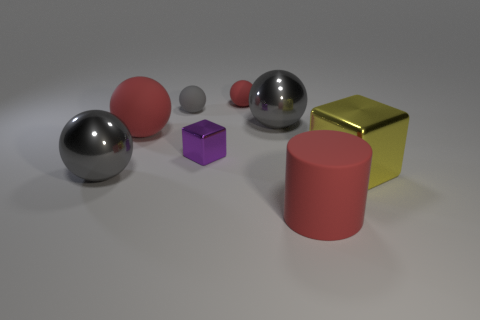How many gray balls must be subtracted to get 1 gray balls? 2 Subtract all red rubber balls. How many balls are left? 3 Subtract all gray blocks. How many gray spheres are left? 3 Subtract all red balls. How many balls are left? 3 Add 2 metal blocks. How many objects exist? 10 Subtract all blue balls. Subtract all green blocks. How many balls are left? 5 Subtract all cubes. How many objects are left? 6 Subtract all gray matte cylinders. Subtract all small blocks. How many objects are left? 7 Add 4 red things. How many red things are left? 7 Add 8 big red objects. How many big red objects exist? 10 